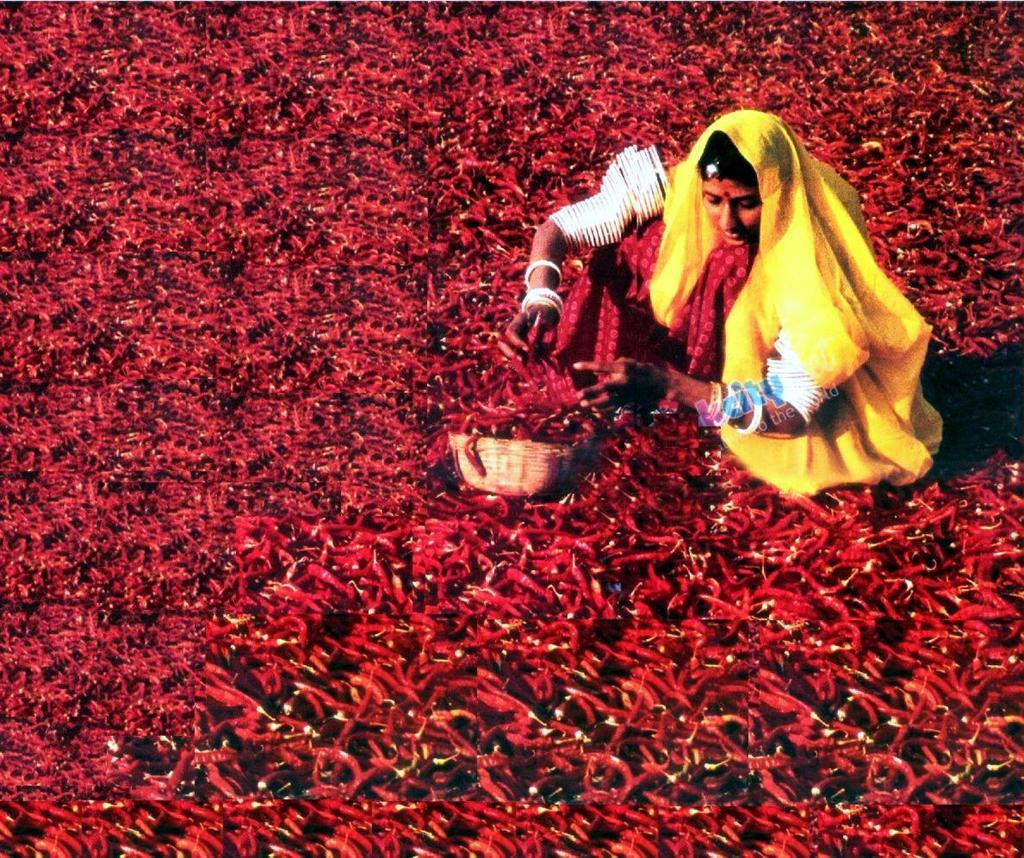Who is the main subject in the image? There is a lady in the image. Where is the lady located in the image? The lady is sitting on the right side of the image. What can be seen in the area of the image? There are chillies in the area of the image. What actor is performing a sorting task in the image? There is no actor performing a sorting task in the image, nor is there any reference to a sorting task or an actor. 